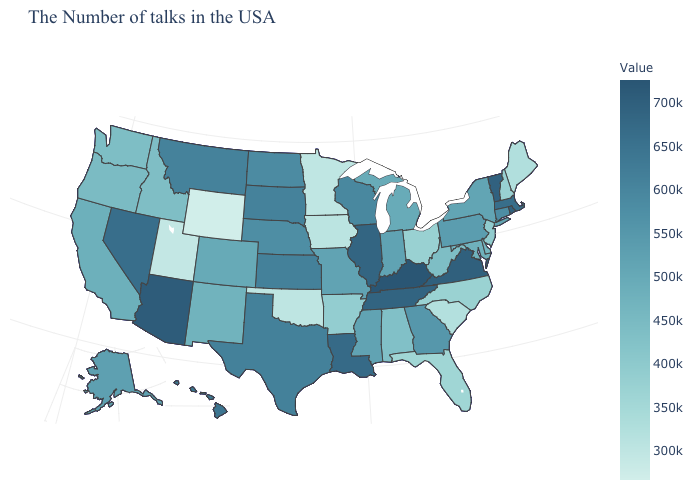Among the states that border Vermont , which have the highest value?
Write a very short answer. Massachusetts. Among the states that border Florida , does Georgia have the highest value?
Short answer required. Yes. Among the states that border Mississippi , does Tennessee have the highest value?
Give a very brief answer. Yes. Does the map have missing data?
Concise answer only. No. Does Nevada have a higher value than West Virginia?
Be succinct. Yes. Among the states that border New Hampshire , does Vermont have the highest value?
Answer briefly. Yes. 